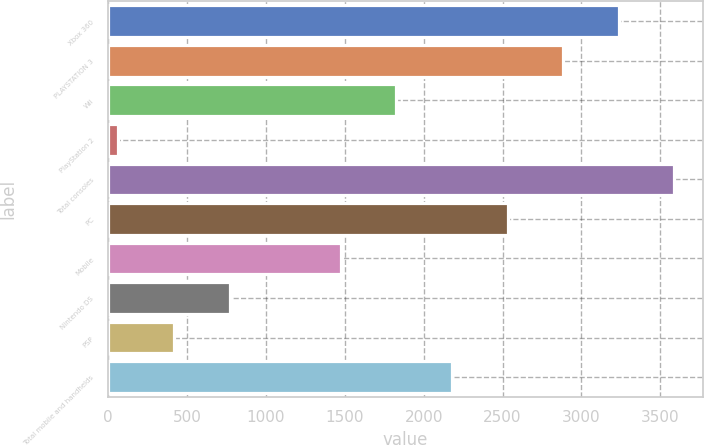<chart> <loc_0><loc_0><loc_500><loc_500><bar_chart><fcel>Xbox 360<fcel>PLAYSTATION 3<fcel>Wii<fcel>PlayStation 2<fcel>Total consoles<fcel>PC<fcel>Mobile<fcel>Nintendo DS<fcel>PSP<fcel>Total mobile and handhelds<nl><fcel>3236.5<fcel>2884<fcel>1826.5<fcel>64<fcel>3589<fcel>2531.5<fcel>1474<fcel>769<fcel>416.5<fcel>2179<nl></chart> 